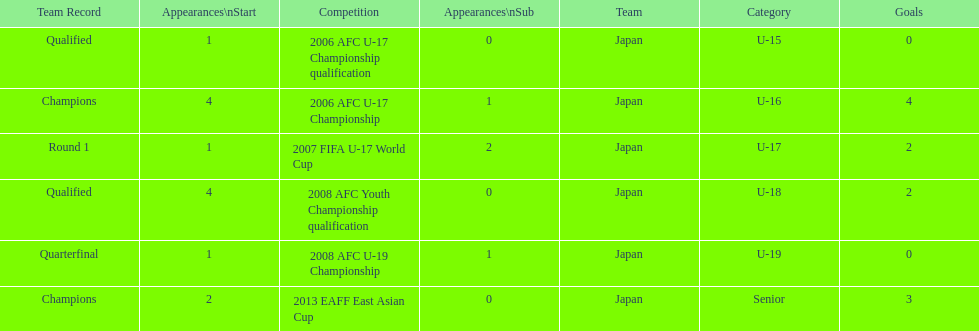What competition did japan compete in 2013? 2013 EAFF East Asian Cup. 